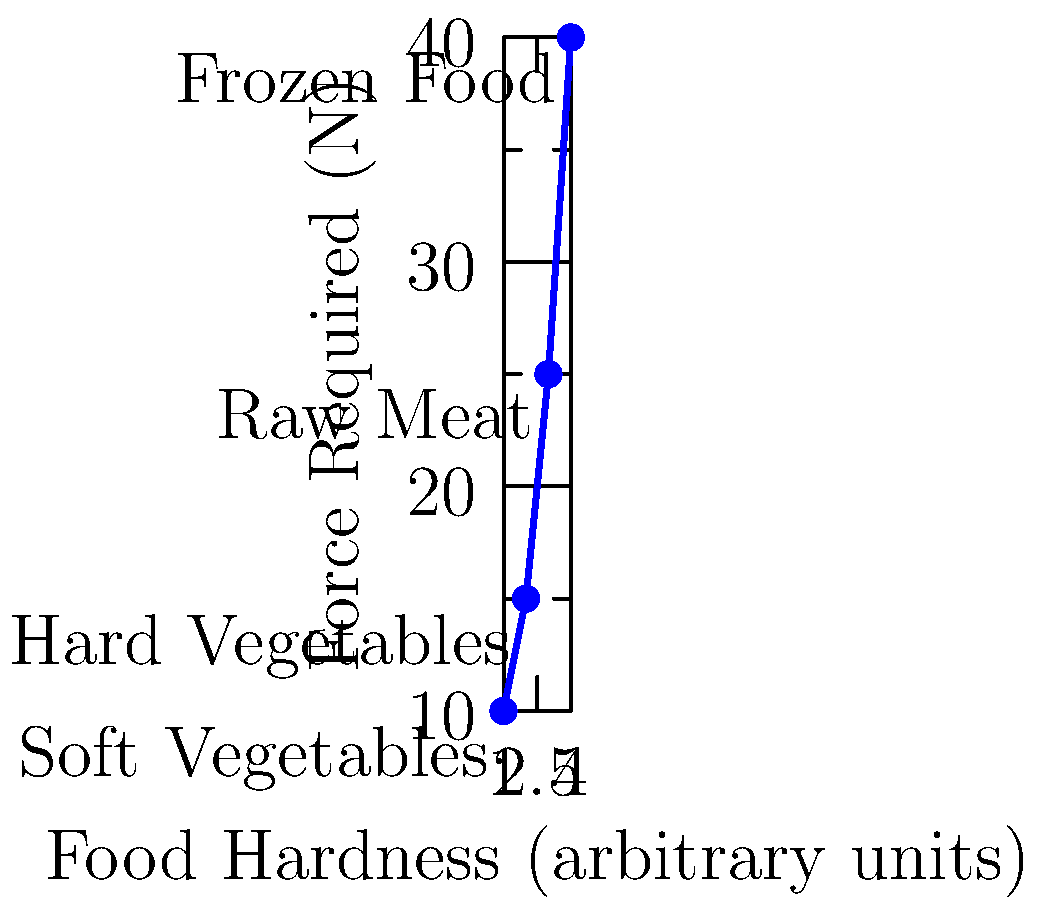As a line cook focused on speed and efficiency, you need to quickly determine the relationship between food hardness and the force required to slice through it. Based on the graph, which mathematical function best describes the relationship between food hardness and the force required to slice through it? To determine the relationship between food hardness and the force required to slice through it, let's analyze the graph step-by-step:

1. Observe the data points:
   - Soft Vegetables: (1, 10)
   - Hard Vegetables: (2, 15)
   - Raw Meat: (3, 25)
   - Frozen Food: (4, 40)

2. Calculate the rate of change between consecutive points:
   - From (1, 10) to (2, 15): $\frac{15-10}{2-1} = 5$
   - From (2, 15) to (3, 25): $\frac{25-15}{3-2} = 10$
   - From (3, 25) to (4, 40): $\frac{40-25}{4-3} = 15$

3. Notice that the rate of change is increasing:
   5 < 10 < 15

4. This increasing rate of change suggests a non-linear relationship.

5. The curve appears to be steepening as the food hardness increases, which is characteristic of an exponential or power function.

6. Given the context of force and resistance in physics, a power function is more likely to describe this relationship.

7. The general form of a power function is $y = ax^b$, where $a$ and $b$ are constants.

Therefore, the relationship between food hardness and the force required to slice through it is best described by a power function.
Answer: Power function 